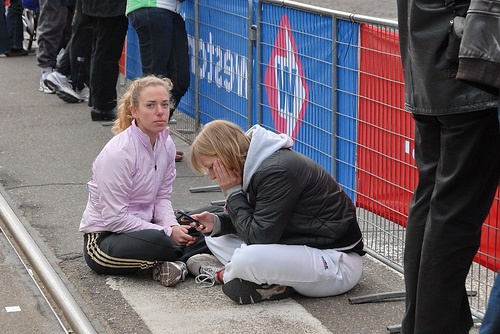Describe the objects in this image and their specific colors. I can see people in black, gray, and darkgray tones, people in black, darkgray, gray, and lavender tones, people in black, darkgray, and lavender tones, people in black, blue, navy, and gray tones, and people in black, gray, and maroon tones in this image. 